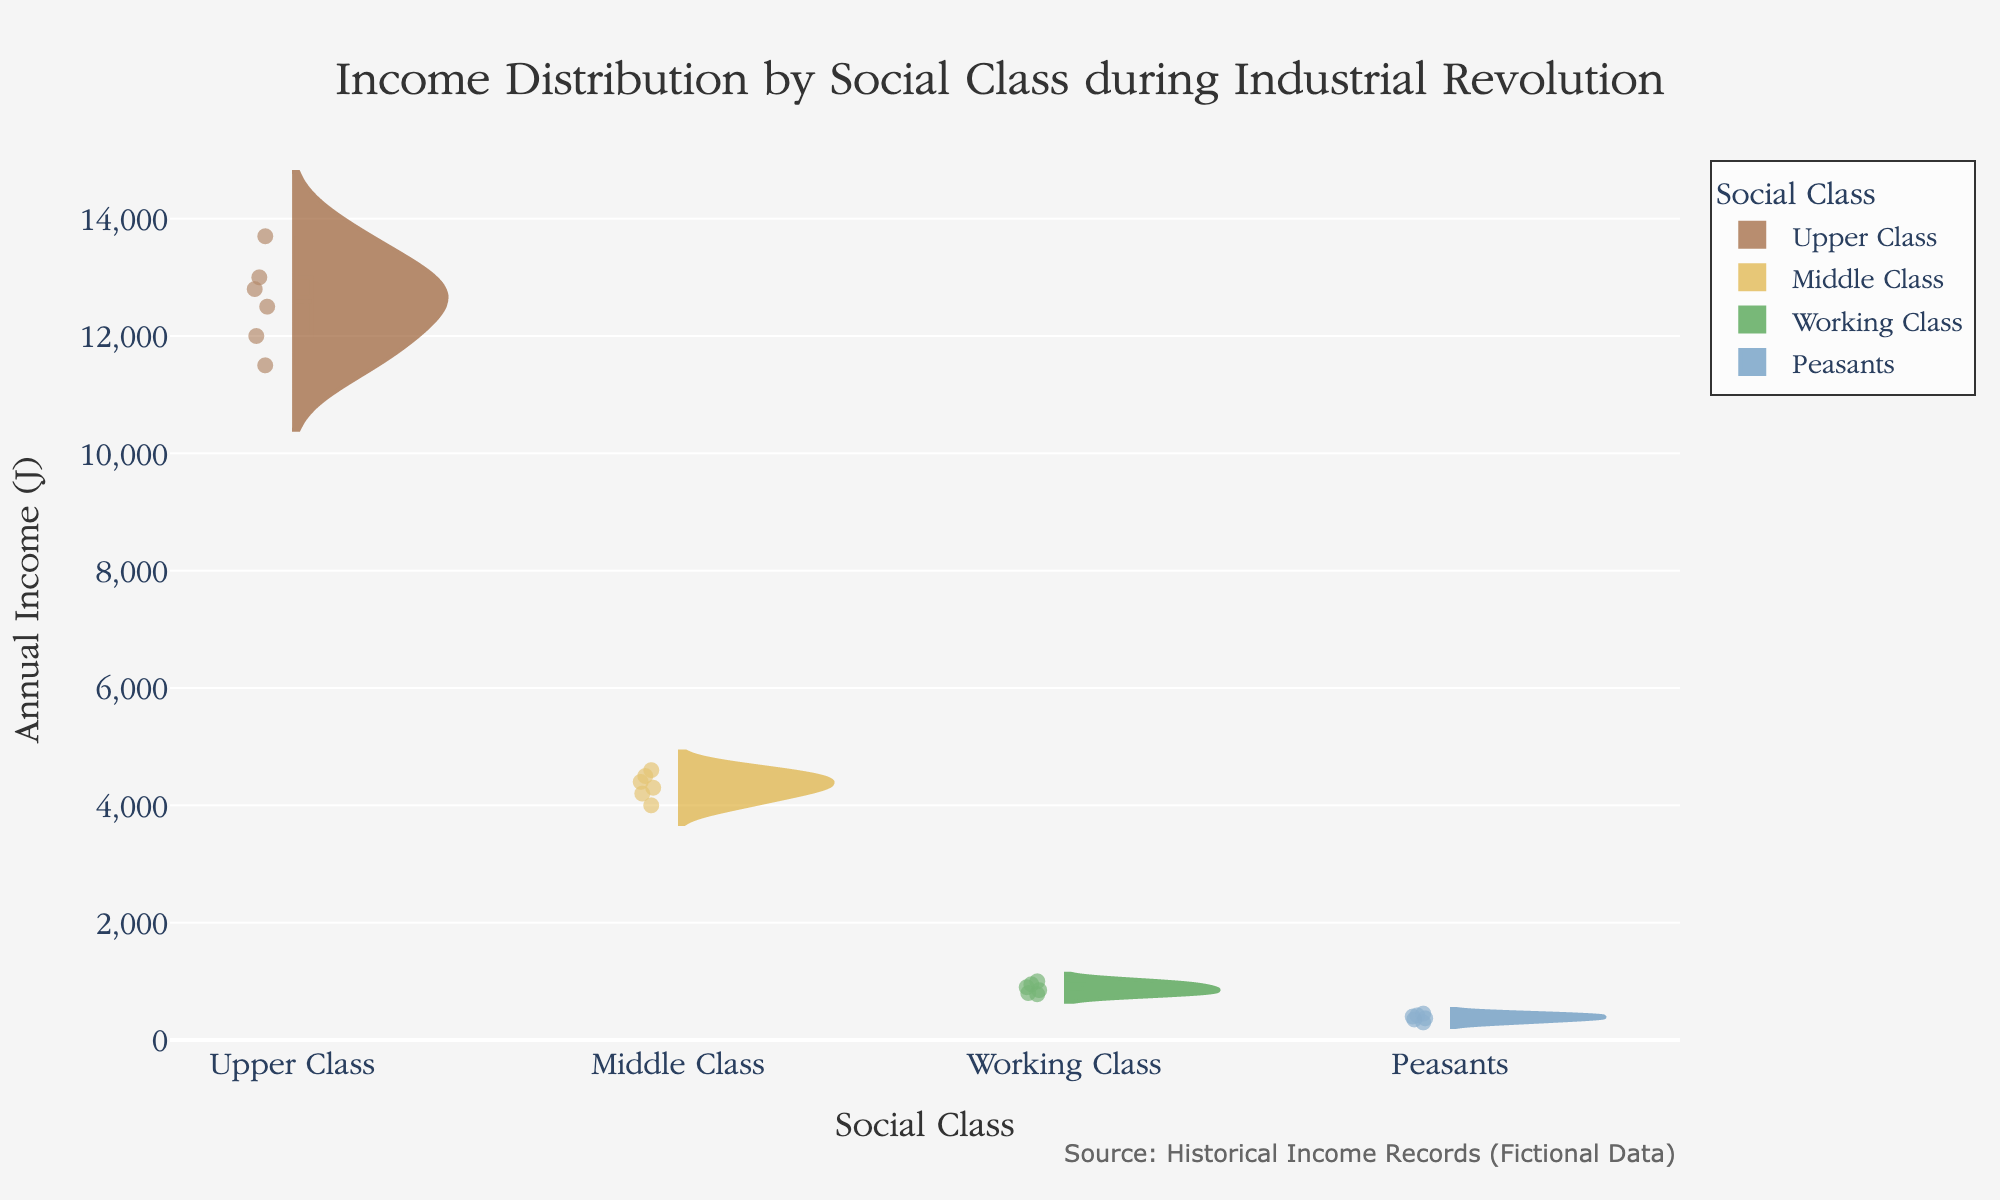Which social class has the highest median income? From the box plot overlays, the median is represented by the white line inside each box. The upper class has the highest median income.
Answer: Upper Class What is the range of incomes for the Middle Class? The range is the difference between the highest and lowest incomes shown in the violin plot for the Middle Class. The highest income is 4600, and the lowest is 4000. So, the range is 4600 - 4000.
Answer: 600 Comparing the upper and lower bounds of the box plots, which social class has the smallest income variation? The income variation can be inferred by the length of the box plot. The Working Class has the smallest box, indicating the smallest income variation.
Answer: Working Class How many distinct data points are represented in the Upper Class? By counting the data points (shown as individual dots) within the violin plot of the Upper Class, there are 6 data points visible.
Answer: 6 Which social class has the lowest maximum income? The maximum income is the highest point represented in each violin plot. The Peasants class has the lowest maximum income at 450.
Answer: Peasants What is the overall shape (distribution) of the income for the Working Class? The Working Class' violin plot shows a denser, compact shape with a peak around 850-950, indicating most incomes are around this range with less spread.
Answer: Dense around 850-950 Are there any outliers in the income data for the Peasants class? Outliers are generally shown as individual dots outside the box in the box plot overlay. The Peasants class does not have any dots beyond the whiskers of the box plot.
Answer: No How does the mean income of the Middle Class compare with its median income? The mean is shown as a dashed line in the violin plot, and the median as a solid line within the box. For the Middle Class, the mean line is slightly higher than the median line.
Answer: Mean is slightly higher Between the Upper and Middle Classes, which has a larger spread of income values? The spread is represented by the width of the violin plots. The Upper Class has a wider violin plot indicating a larger spread of income values compared to the Middle Class.
Answer: Upper Class What is the interquartile range (IQR) for the Working Class? The IQR is the range between the first quartile (bottom of the box) and the third quartile (top of the box). For the Working Class, these are approximately at 800 and 950, making the IQR 950 - 800.
Answer: 150 